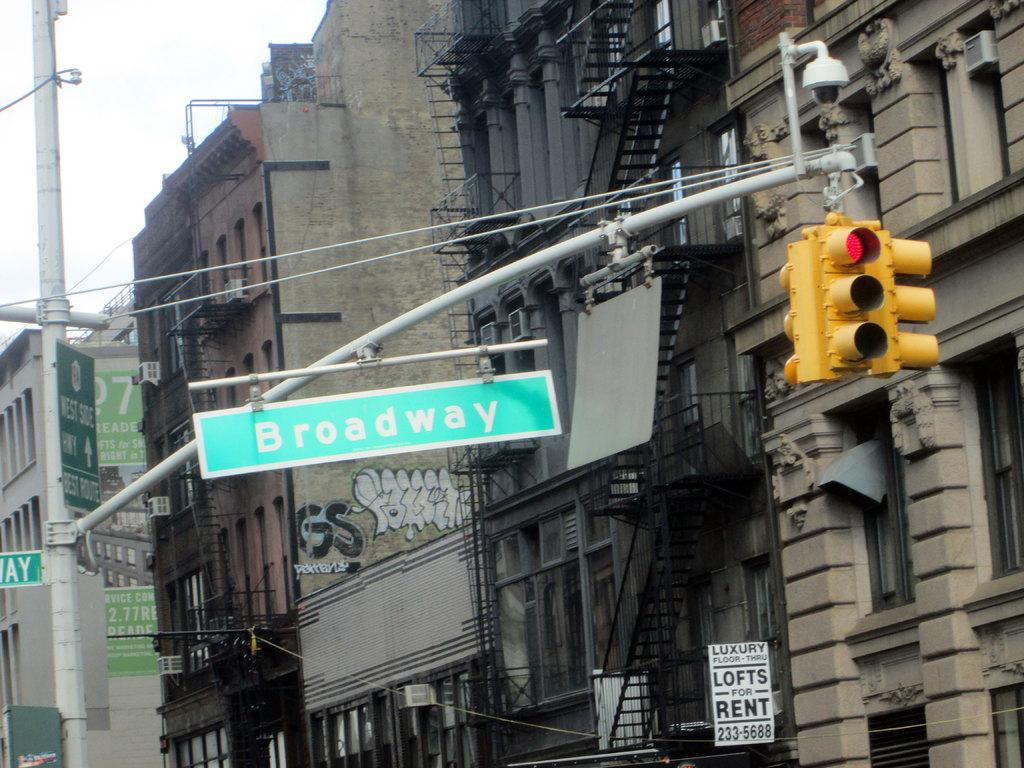Provide a one-sentence caption for the provided image. Lofts are for rent in the building near Broadway. 